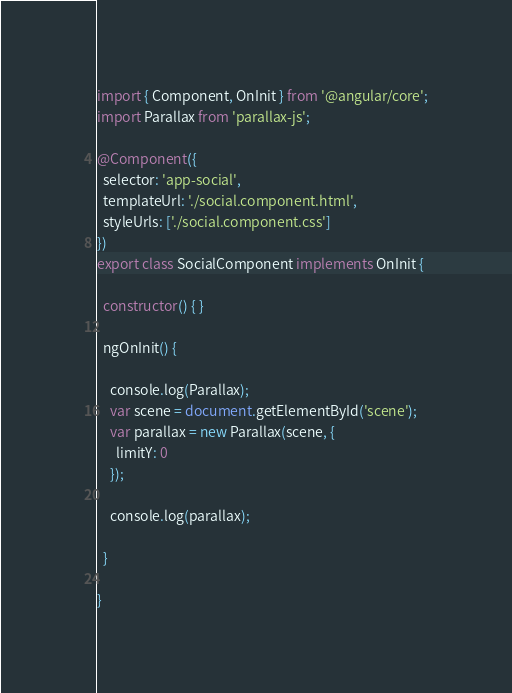Convert code to text. <code><loc_0><loc_0><loc_500><loc_500><_TypeScript_>import { Component, OnInit } from '@angular/core';
import Parallax from 'parallax-js';

@Component({
  selector: 'app-social',
  templateUrl: './social.component.html',
  styleUrls: ['./social.component.css']
})
export class SocialComponent implements OnInit {

  constructor() { }

  ngOnInit() {

    console.log(Parallax);
    var scene = document.getElementById('scene');
    var parallax = new Parallax(scene, {
      limitY: 0
    });

    console.log(parallax);

  }

}
</code> 